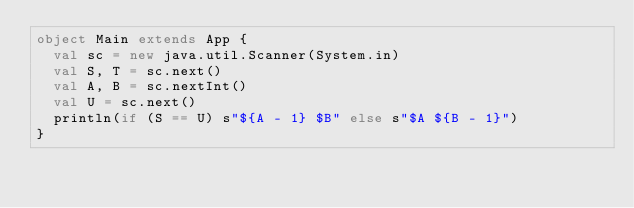<code> <loc_0><loc_0><loc_500><loc_500><_Scala_>object Main extends App {
  val sc = new java.util.Scanner(System.in)
  val S, T = sc.next()
  val A, B = sc.nextInt()
  val U = sc.next()
  println(if (S == U) s"${A - 1} $B" else s"$A ${B - 1}")
}
</code> 